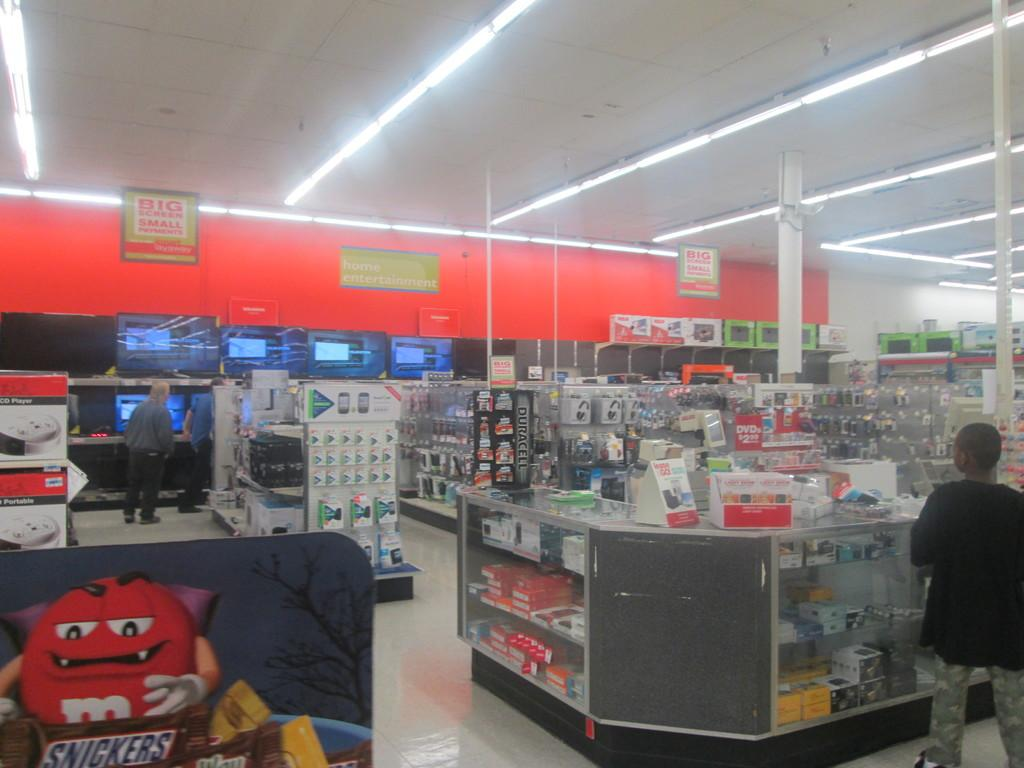<image>
Write a terse but informative summary of the picture. A grocery store has a display that shows a snickers bar. 